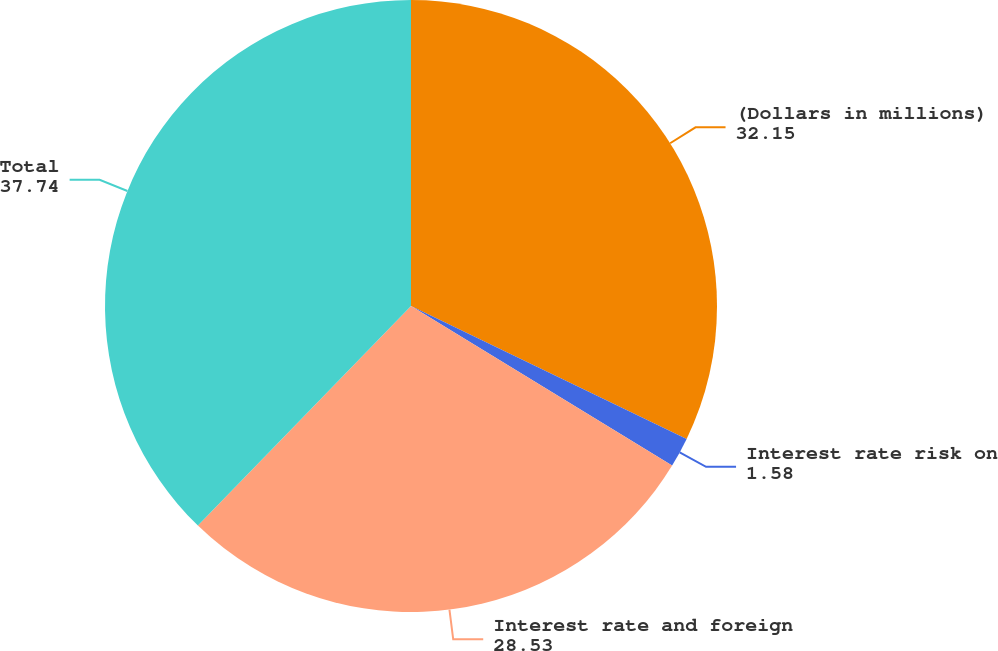Convert chart to OTSL. <chart><loc_0><loc_0><loc_500><loc_500><pie_chart><fcel>(Dollars in millions)<fcel>Interest rate risk on<fcel>Interest rate and foreign<fcel>Total<nl><fcel>32.15%<fcel>1.58%<fcel>28.53%<fcel>37.74%<nl></chart> 